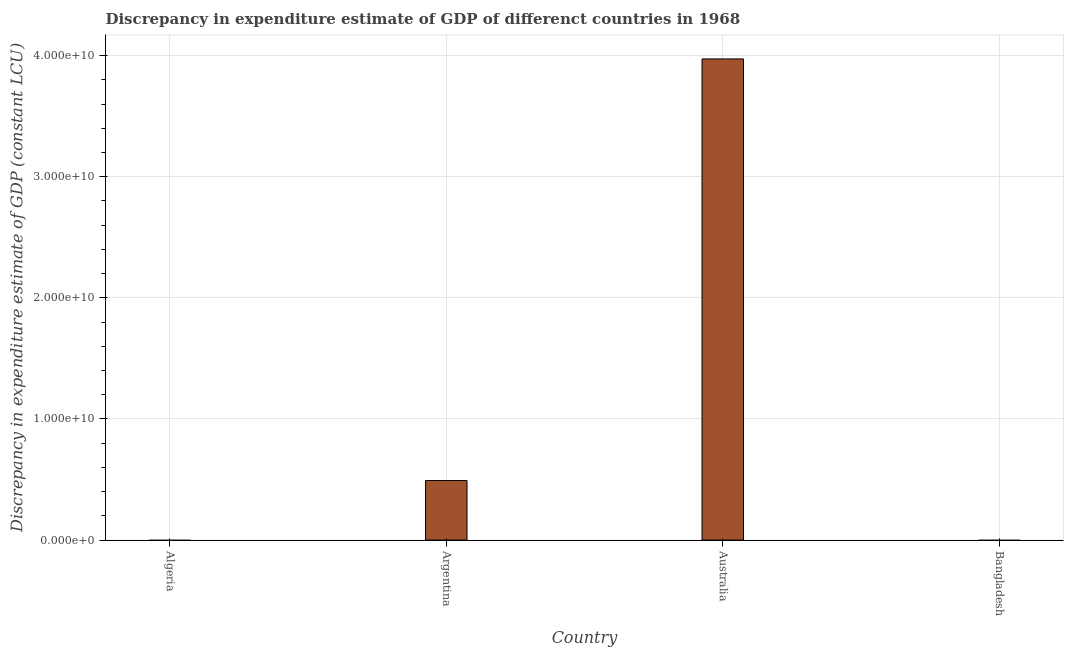Does the graph contain any zero values?
Offer a very short reply. Yes. What is the title of the graph?
Make the answer very short. Discrepancy in expenditure estimate of GDP of differenct countries in 1968. What is the label or title of the X-axis?
Make the answer very short. Country. What is the label or title of the Y-axis?
Ensure brevity in your answer.  Discrepancy in expenditure estimate of GDP (constant LCU). Across all countries, what is the maximum discrepancy in expenditure estimate of gdp?
Offer a terse response. 3.97e+1. In which country was the discrepancy in expenditure estimate of gdp maximum?
Provide a succinct answer. Australia. What is the sum of the discrepancy in expenditure estimate of gdp?
Offer a very short reply. 4.46e+1. What is the average discrepancy in expenditure estimate of gdp per country?
Your answer should be very brief. 1.12e+1. What is the median discrepancy in expenditure estimate of gdp?
Keep it short and to the point. 2.46e+09. What is the ratio of the discrepancy in expenditure estimate of gdp in Argentina to that in Australia?
Keep it short and to the point. 0.12. What is the difference between the highest and the lowest discrepancy in expenditure estimate of gdp?
Give a very brief answer. 3.97e+1. In how many countries, is the discrepancy in expenditure estimate of gdp greater than the average discrepancy in expenditure estimate of gdp taken over all countries?
Give a very brief answer. 1. How many bars are there?
Make the answer very short. 2. Are all the bars in the graph horizontal?
Provide a short and direct response. No. What is the difference between two consecutive major ticks on the Y-axis?
Give a very brief answer. 1.00e+1. What is the Discrepancy in expenditure estimate of GDP (constant LCU) in Argentina?
Your answer should be very brief. 4.92e+09. What is the Discrepancy in expenditure estimate of GDP (constant LCU) in Australia?
Keep it short and to the point. 3.97e+1. What is the difference between the Discrepancy in expenditure estimate of GDP (constant LCU) in Argentina and Australia?
Give a very brief answer. -3.48e+1. What is the ratio of the Discrepancy in expenditure estimate of GDP (constant LCU) in Argentina to that in Australia?
Offer a very short reply. 0.12. 